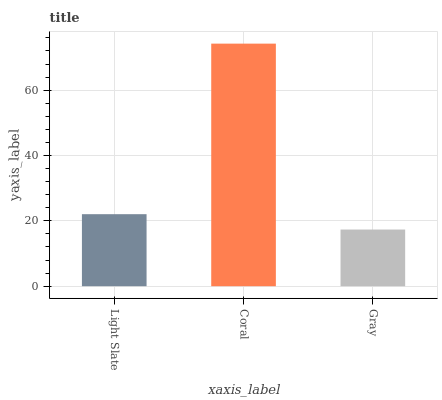Is Gray the minimum?
Answer yes or no. Yes. Is Coral the maximum?
Answer yes or no. Yes. Is Coral the minimum?
Answer yes or no. No. Is Gray the maximum?
Answer yes or no. No. Is Coral greater than Gray?
Answer yes or no. Yes. Is Gray less than Coral?
Answer yes or no. Yes. Is Gray greater than Coral?
Answer yes or no. No. Is Coral less than Gray?
Answer yes or no. No. Is Light Slate the high median?
Answer yes or no. Yes. Is Light Slate the low median?
Answer yes or no. Yes. Is Coral the high median?
Answer yes or no. No. Is Gray the low median?
Answer yes or no. No. 